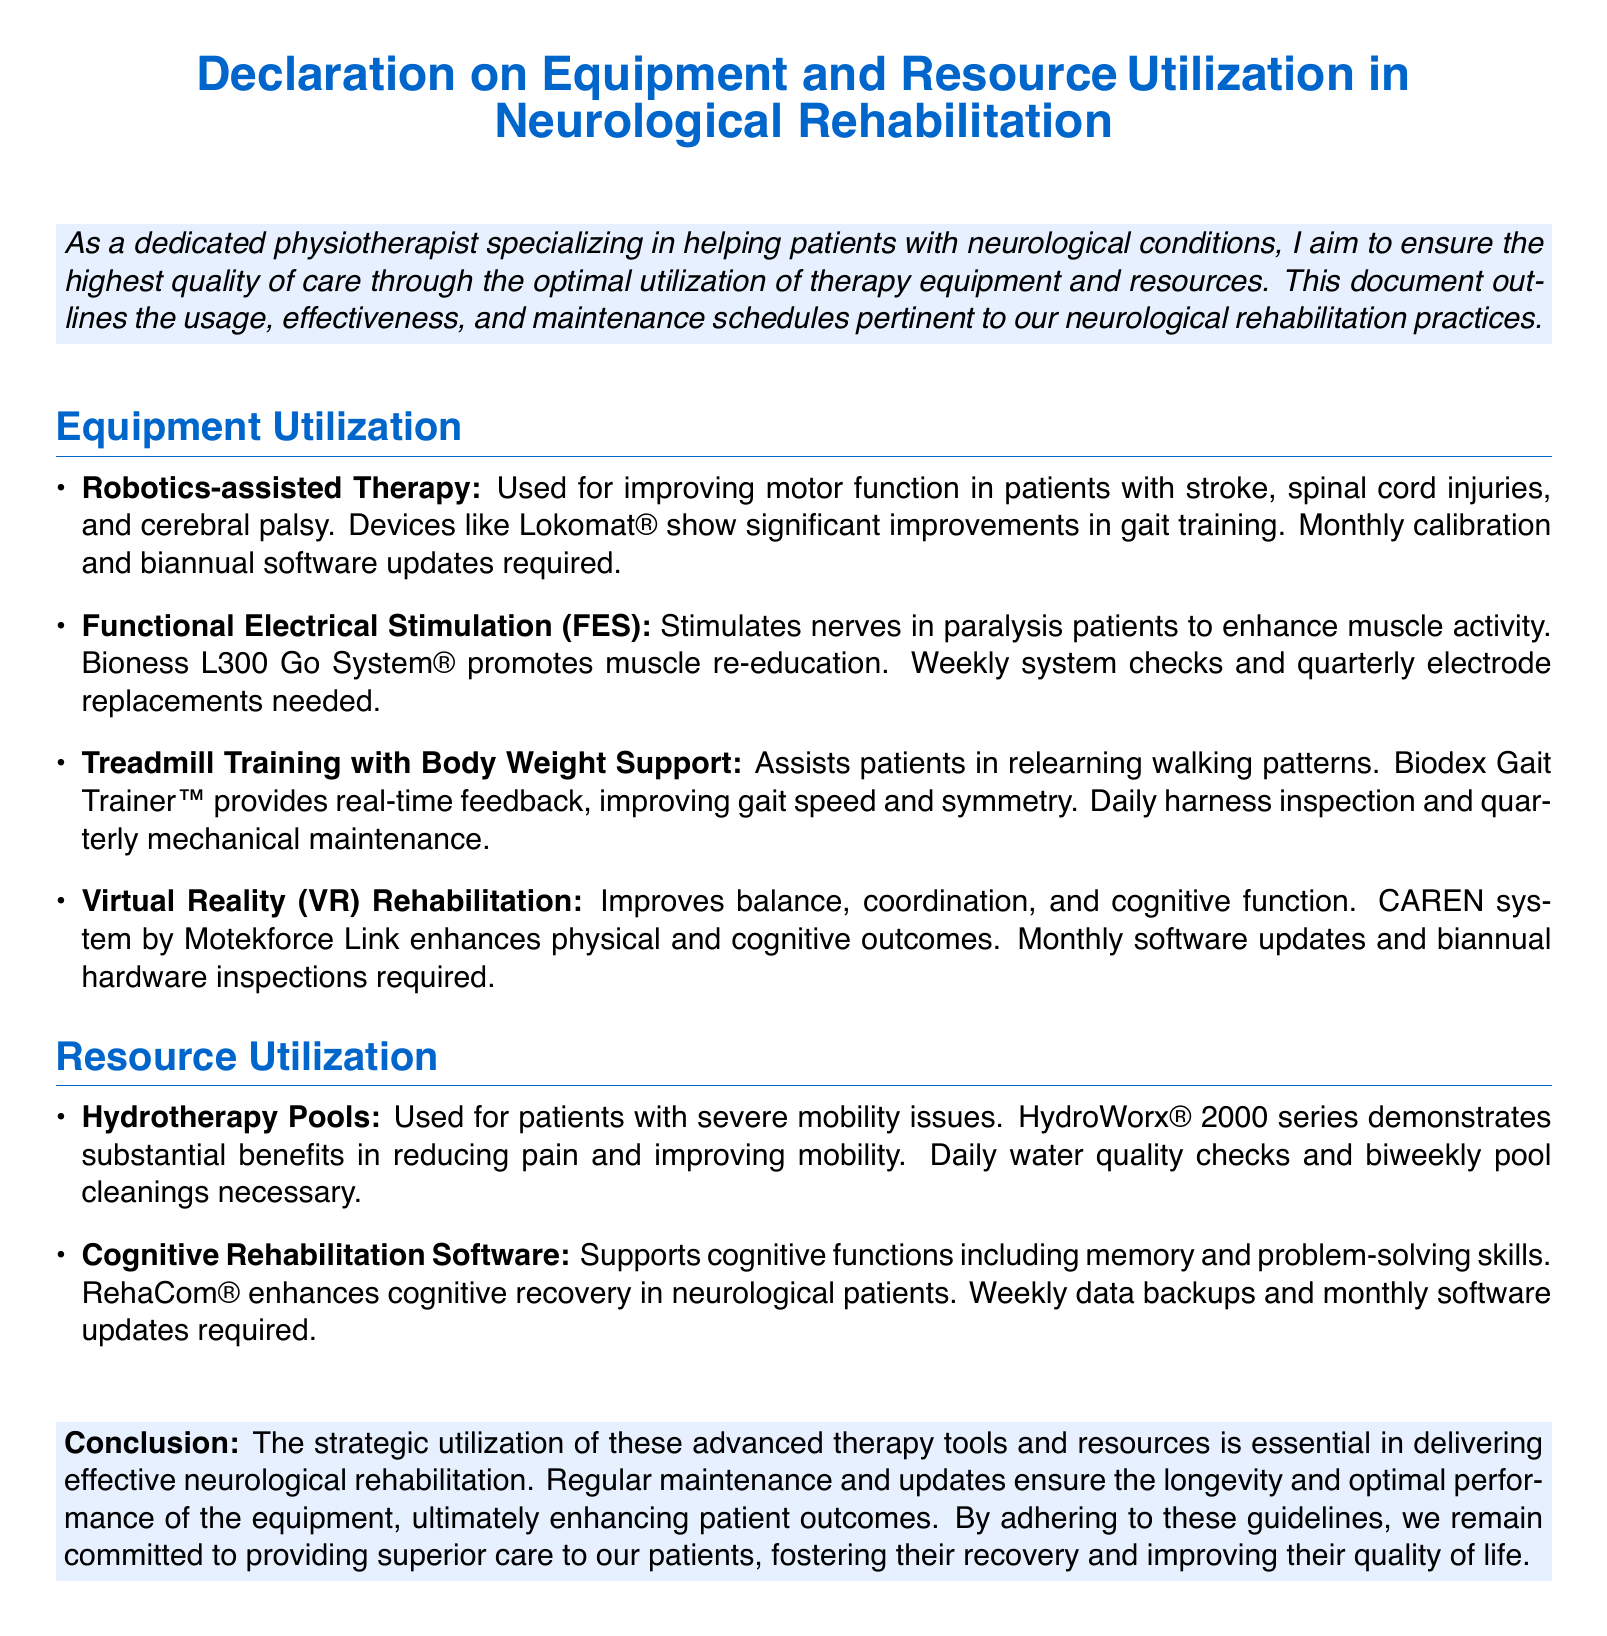what is the purpose of this document? The document outlines the usage, effectiveness, and maintenance schedules pertinent to neurological rehabilitation practices.
Answer: Quality of care what equipment is used for improving motor function in stroke patients? The equipment mentioned is Robotics-assisted Therapy which includes devices like Lokomat®.
Answer: Lokomat® how often are system checks required for the FES device? The document states that weekly system checks are needed for the Bioness L300 Go System®.
Answer: Weekly what therapy is used to enhance balance, coordination, and cognitive function? The therapy mentioned for improving these functions is Virtual Reality Rehabilitation using the CAREN system.
Answer: Virtual Reality Rehabilitation how frequently must the Hydrotherapy Pools be cleaned? The document indicates that biweekly pool cleanings are necessary for HydroWorx® 2000 series.
Answer: Biweekly how does the Treadmill Training with Body Weight Support aid patients? It assists patients in relearning walking patterns by providing real-time feedback.
Answer: Relearning walking patterns how often are software updates required for the Cognitive Rehabilitation Software? The document mentions that monthly software updates are required for RehaCom®.
Answer: Monthly what is the primary benefit of using Robotics-assisted Therapy? The primary benefit is significant improvements in gait training for patients with various neurological conditions.
Answer: Gait training what is a key maintenance task for the Virtual Reality system? Monthly software updates are required for the CAREN system.
Answer: Monthly software updates 